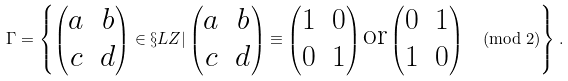Convert formula to latex. <formula><loc_0><loc_0><loc_500><loc_500>\Gamma = \left \{ \begin{pmatrix} a & b \\ c & d \end{pmatrix} \in \S L Z | \begin{pmatrix} a & b \\ c & d \end{pmatrix} \equiv \begin{pmatrix} 1 & 0 \\ 0 & 1 \end{pmatrix} \text {or} \begin{pmatrix} 0 & 1 \\ 1 & 0 \end{pmatrix} \pmod { 2 } \right \} .</formula> 